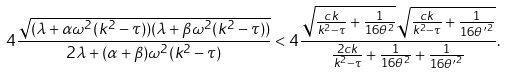Convert formula to latex. <formula><loc_0><loc_0><loc_500><loc_500>4 \frac { \sqrt { ( \lambda + \alpha \omega ^ { 2 } ( k ^ { 2 } - \tau ) ) ( \lambda + \beta \omega ^ { 2 } ( k ^ { 2 } - \tau ) ) } } { 2 \lambda + ( \alpha + \beta ) \omega ^ { 2 } ( k ^ { 2 } - \tau ) } < 4 \frac { \sqrt { \frac { c k } { k ^ { 2 } - \tau } + \frac { 1 } { 1 6 \theta ^ { 2 } } } \sqrt { \frac { c k } { k ^ { 2 } - \tau } + \frac { 1 } { 1 6 { \theta ^ { \prime } } ^ { 2 } } } } { \frac { 2 c k } { k ^ { 2 } - \tau } + \frac { 1 } { 1 6 \theta ^ { 2 } } + \frac { 1 } { 1 6 { \theta ^ { \prime } } ^ { 2 } } } .</formula> 